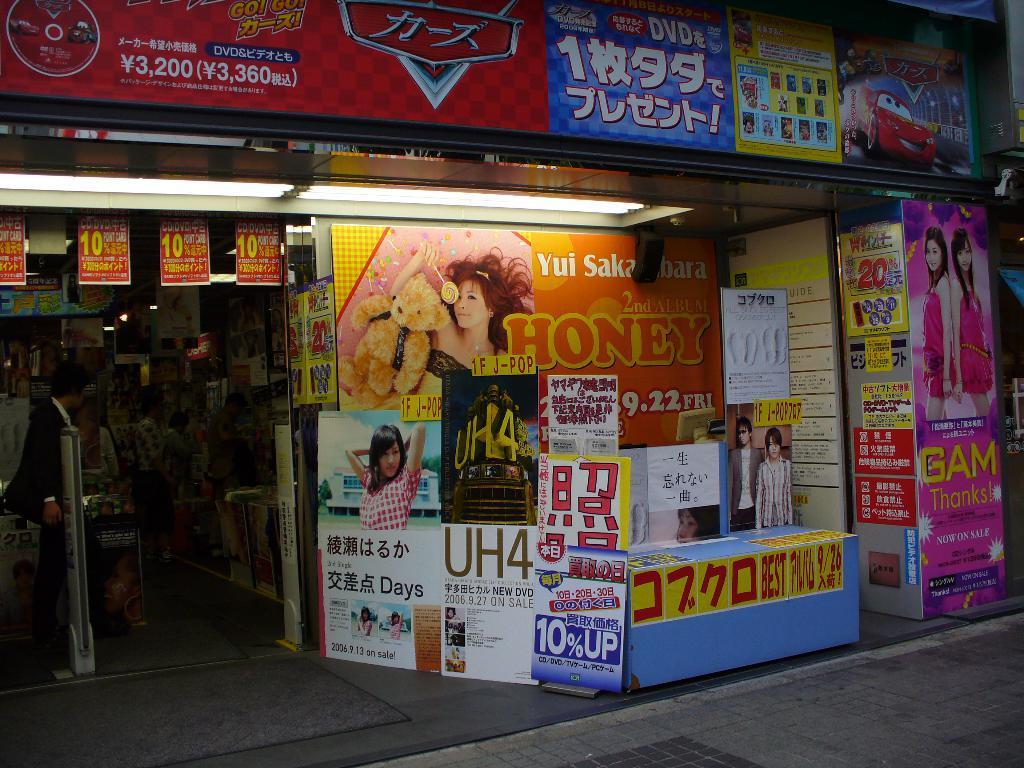Describe this image in one or two sentences. In the image we can see a shop, here we can see posters and on the posters we can see text and pictures. Here we can see the road, lights and we can see a person standing, wearing clothes. 